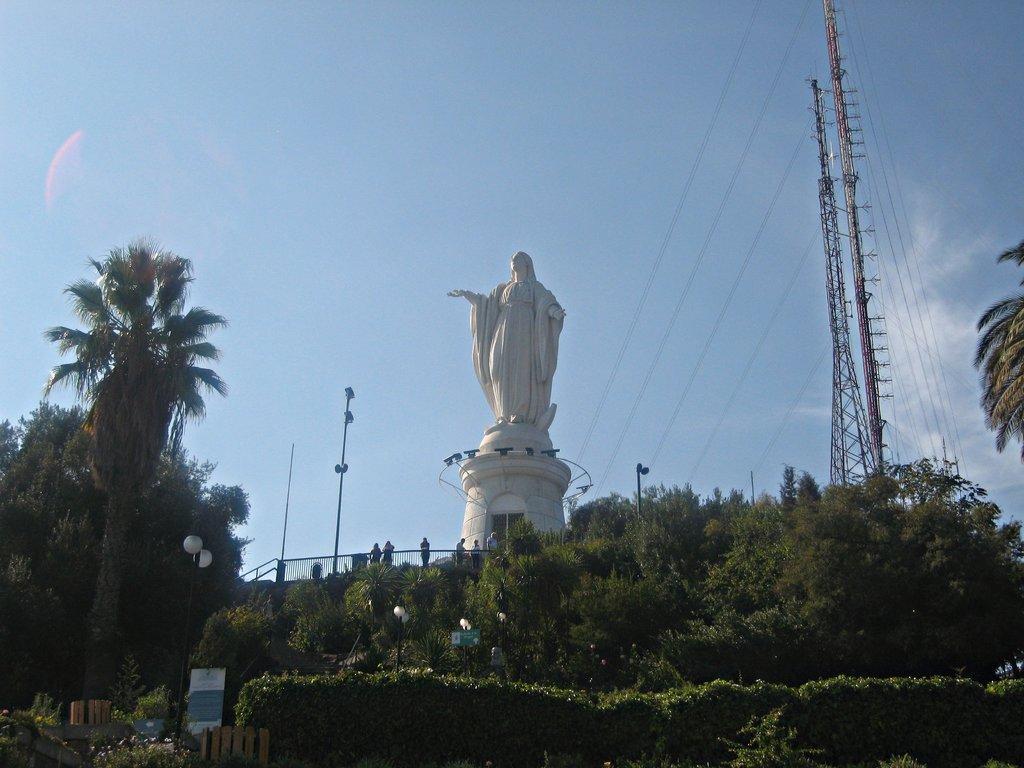In one or two sentences, can you explain what this image depicts? In the foreground of the picture there are plants, trees, poles and other objects. In the center of the picture there is a sculpture. On the right there are current poles and cables. In the center of the picture there are people, poles and railing. Sky is sunny. 